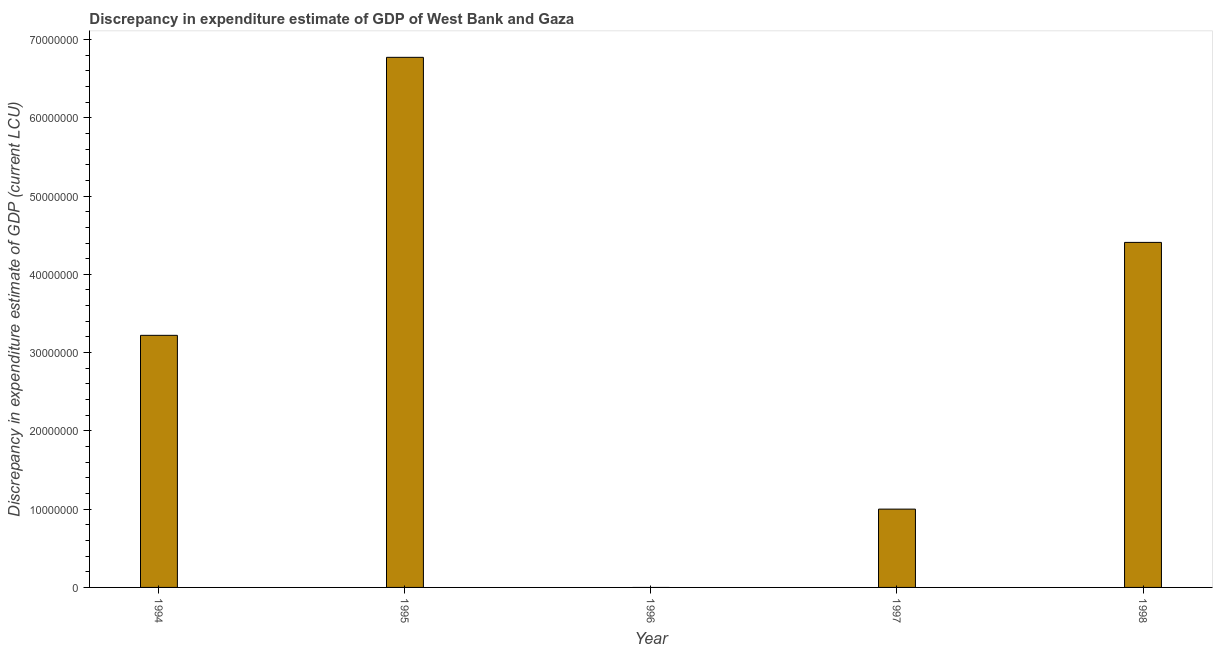Does the graph contain any zero values?
Ensure brevity in your answer.  Yes. Does the graph contain grids?
Offer a very short reply. No. What is the title of the graph?
Provide a short and direct response. Discrepancy in expenditure estimate of GDP of West Bank and Gaza. What is the label or title of the X-axis?
Offer a terse response. Year. What is the label or title of the Y-axis?
Keep it short and to the point. Discrepancy in expenditure estimate of GDP (current LCU). What is the discrepancy in expenditure estimate of gdp in 1998?
Provide a short and direct response. 4.41e+07. Across all years, what is the maximum discrepancy in expenditure estimate of gdp?
Your answer should be compact. 6.77e+07. Across all years, what is the minimum discrepancy in expenditure estimate of gdp?
Your answer should be very brief. 0. What is the sum of the discrepancy in expenditure estimate of gdp?
Your answer should be compact. 1.54e+08. What is the difference between the discrepancy in expenditure estimate of gdp in 1994 and 1995?
Your answer should be compact. -3.55e+07. What is the average discrepancy in expenditure estimate of gdp per year?
Your response must be concise. 3.08e+07. What is the median discrepancy in expenditure estimate of gdp?
Keep it short and to the point. 3.22e+07. What is the ratio of the discrepancy in expenditure estimate of gdp in 1995 to that in 1997?
Make the answer very short. 6.77. What is the difference between the highest and the second highest discrepancy in expenditure estimate of gdp?
Your answer should be compact. 2.36e+07. What is the difference between the highest and the lowest discrepancy in expenditure estimate of gdp?
Give a very brief answer. 6.77e+07. In how many years, is the discrepancy in expenditure estimate of gdp greater than the average discrepancy in expenditure estimate of gdp taken over all years?
Provide a succinct answer. 3. What is the difference between two consecutive major ticks on the Y-axis?
Keep it short and to the point. 1.00e+07. Are the values on the major ticks of Y-axis written in scientific E-notation?
Offer a very short reply. No. What is the Discrepancy in expenditure estimate of GDP (current LCU) in 1994?
Offer a terse response. 3.22e+07. What is the Discrepancy in expenditure estimate of GDP (current LCU) of 1995?
Provide a short and direct response. 6.77e+07. What is the Discrepancy in expenditure estimate of GDP (current LCU) of 1996?
Your answer should be very brief. 0. What is the Discrepancy in expenditure estimate of GDP (current LCU) of 1997?
Keep it short and to the point. 1.00e+07. What is the Discrepancy in expenditure estimate of GDP (current LCU) of 1998?
Make the answer very short. 4.41e+07. What is the difference between the Discrepancy in expenditure estimate of GDP (current LCU) in 1994 and 1995?
Offer a terse response. -3.55e+07. What is the difference between the Discrepancy in expenditure estimate of GDP (current LCU) in 1994 and 1997?
Keep it short and to the point. 2.22e+07. What is the difference between the Discrepancy in expenditure estimate of GDP (current LCU) in 1994 and 1998?
Your answer should be very brief. -1.19e+07. What is the difference between the Discrepancy in expenditure estimate of GDP (current LCU) in 1995 and 1997?
Offer a very short reply. 5.77e+07. What is the difference between the Discrepancy in expenditure estimate of GDP (current LCU) in 1995 and 1998?
Give a very brief answer. 2.36e+07. What is the difference between the Discrepancy in expenditure estimate of GDP (current LCU) in 1997 and 1998?
Your answer should be compact. -3.41e+07. What is the ratio of the Discrepancy in expenditure estimate of GDP (current LCU) in 1994 to that in 1995?
Your answer should be very brief. 0.48. What is the ratio of the Discrepancy in expenditure estimate of GDP (current LCU) in 1994 to that in 1997?
Your answer should be compact. 3.22. What is the ratio of the Discrepancy in expenditure estimate of GDP (current LCU) in 1994 to that in 1998?
Your answer should be very brief. 0.73. What is the ratio of the Discrepancy in expenditure estimate of GDP (current LCU) in 1995 to that in 1997?
Ensure brevity in your answer.  6.77. What is the ratio of the Discrepancy in expenditure estimate of GDP (current LCU) in 1995 to that in 1998?
Ensure brevity in your answer.  1.54. What is the ratio of the Discrepancy in expenditure estimate of GDP (current LCU) in 1997 to that in 1998?
Provide a succinct answer. 0.23. 